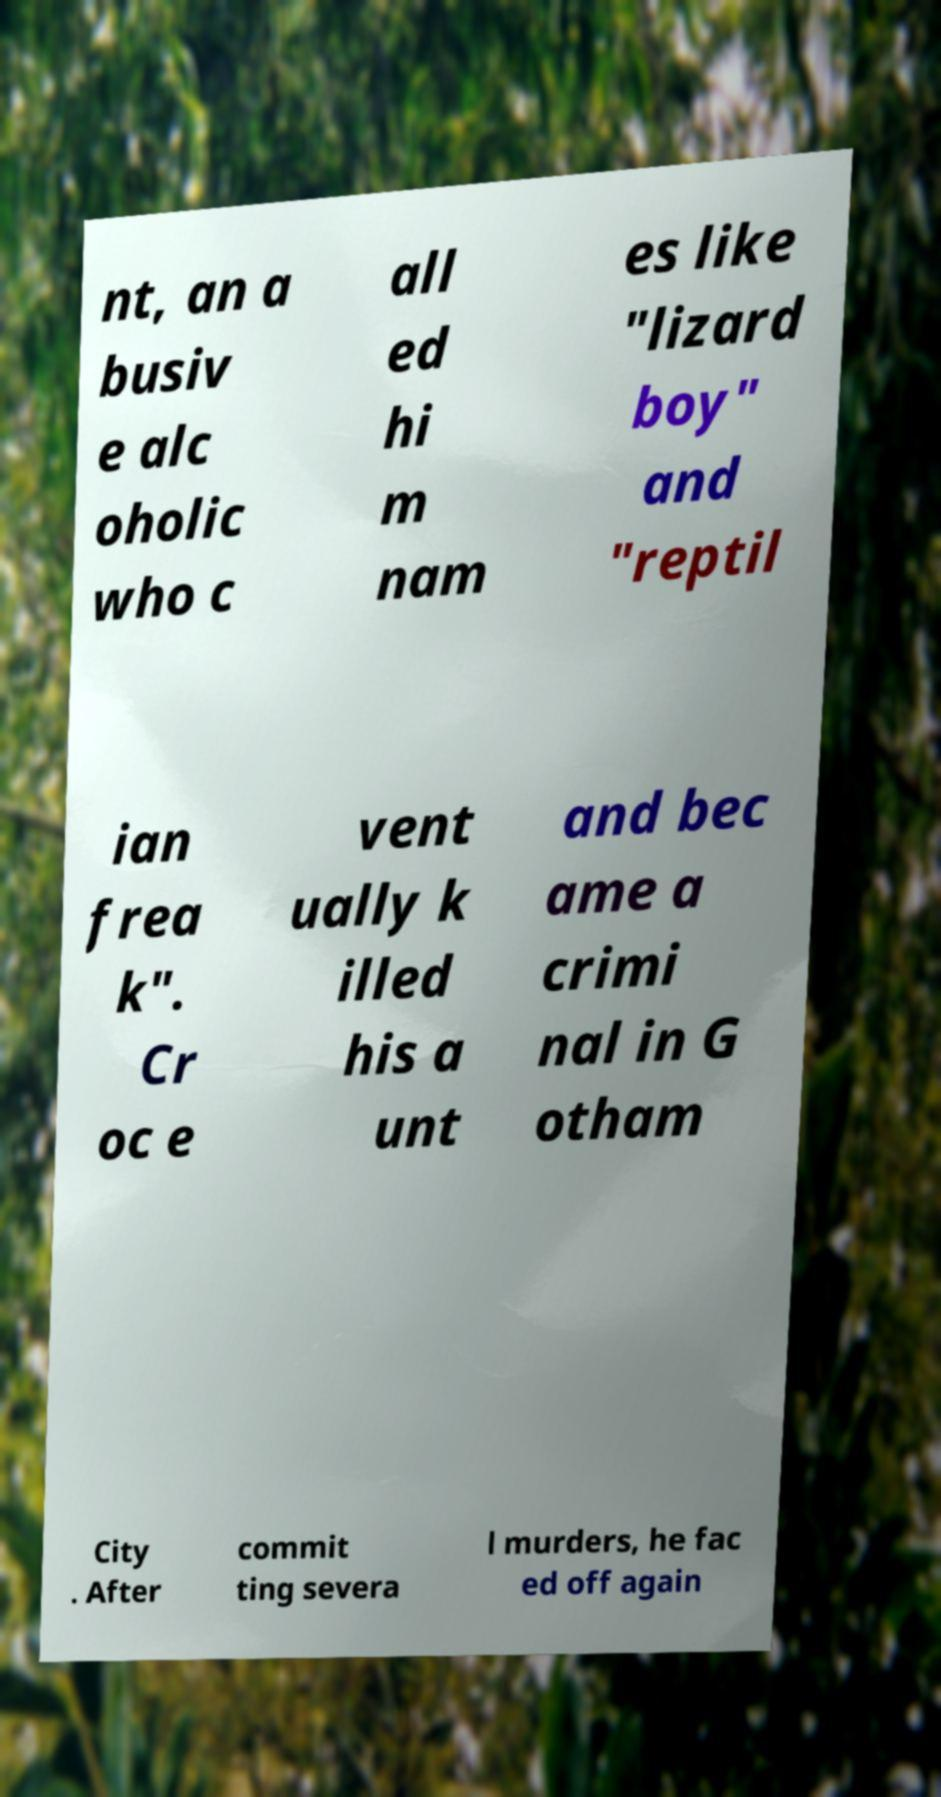There's text embedded in this image that I need extracted. Can you transcribe it verbatim? nt, an a busiv e alc oholic who c all ed hi m nam es like "lizard boy" and "reptil ian frea k". Cr oc e vent ually k illed his a unt and bec ame a crimi nal in G otham City . After commit ting severa l murders, he fac ed off again 